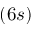Convert formula to latex. <formula><loc_0><loc_0><loc_500><loc_500>( 6 s )</formula> 